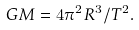Convert formula to latex. <formula><loc_0><loc_0><loc_500><loc_500>G M = 4 \pi ^ { 2 } R ^ { 3 } / T ^ { 2 } .</formula> 